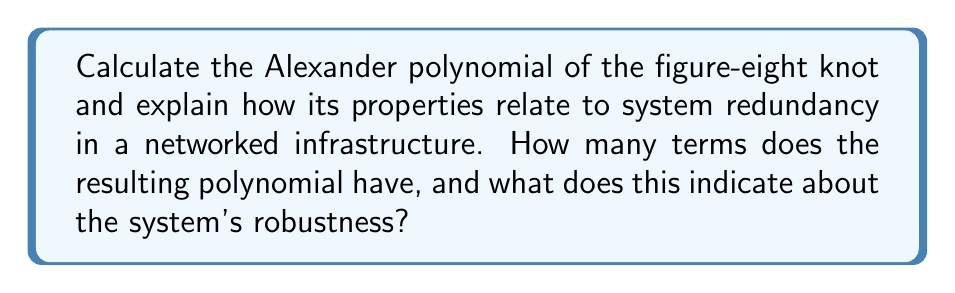What is the answer to this math problem? Let's approach this step-by-step:

1) First, we need to create a diagram of the figure-eight knot and label its crossings:

[asy]
import geometry;

pair A = (0,0), B = (1,1), C = (2,0), D = (1,-1);
pair E = (0.5,0.5), F = (1.5,0.5), G = (0.5,-0.5), H = (1.5,-0.5);

draw(A--E--F--C--H--G--A);
draw(B--F--H--D--G--E--B);

label("1", (0.75,0.75), N);
label("2", (1.25,0.75), N);
label("3", (1.25,-0.75), S);
label("4", (0.75,-0.75), S);

dot(E);
dot(F);
dot(G);
dot(H);
[/asy]

2) Now, we create the Alexander matrix. For a knot with n crossings, this is an (n-1) x n matrix. The figure-eight knot has 4 crossings, so our matrix will be 3x4.

3) For each crossing, we write an equation:
   Crossing 1: $t^{-1}x_1 - x_2 + (1-t^{-1})x_4 = 0$
   Crossing 2: $tx_2 - x_3 + (1-t)x_1 = 0$
   Crossing 3: $t^{-1}x_3 - x_4 + (1-t^{-1})x_2 = 0$
   Crossing 4: $tx_4 - x_1 + (1-t)x_3 = 0$

4) We can drop any one of these equations. Let's drop the last one. Our matrix is:

   $$\begin{pmatrix}
   t^{-1} & -1 & 0 & 1-t^{-1} \\
   1-t & t & -1 & 0 \\
   0 & 1-t^{-1} & t^{-1} & -1
   \end{pmatrix}$$

5) The Alexander polynomial is the determinant of any (n-1) x (n-1) minor of this matrix, divided by $(t^{1/2} - t^{-1/2})^{n-2}$. Let's choose the first three columns:

   $$\Delta(t) = \frac{1}{t^{1/2} - t^{-1/2}} \det\begin{pmatrix}
   t^{-1} & -1 & 0 \\
   1-t & t & -1 \\
   0 & 1-t^{-1} & t^{-1}
   \end{pmatrix}$$

6) Calculating this determinant:

   $\Delta(t) = \frac{1}{t^{1/2} - t^{-1/2}} (t^{-2} - t^{-1} + 1 - t + t^2)$

7) Simplifying:

   $\Delta(t) = t^{-1} - 1 + t$

The Alexander polynomial has 3 terms, which indicates a high level of complexity and interconnectedness in the knot structure. In the context of network infrastructure, this suggests a system with multiple redundant pathways and a high degree of robustness. The symmetry of the polynomial (it reads the same forwards and backwards) also indicates a well-balanced system design.
Answer: $\Delta(t) = t^{-1} - 1 + t$; 3 terms; high robustness 